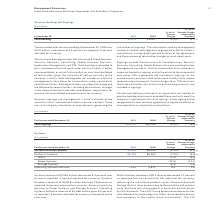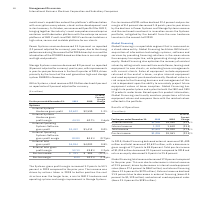According to International Business Machines's financial document, What caused the Systems Hardware revenue to decline? driven primarily by declines in Power Systems and Storage Systems.. The document states: "ent as reported (6 percent adjusted for currency), driven primarily by declines in Power Systems and Storage Systems. Operating Systems Software reven..." Also, What caused the IBM Z revenue to decline? IBM Z revenue decreased 1.1 percent as reported but was essentially flat adjusted for currency, reflecting the mainframe product cycles. Revenue declined through the first three quarters due to the end of the z14 product cycle, but there was strong growth in the fourth quarter driven by z15 shipments.. The document states: "Within Systems Hardware, IBM Z revenue decreased 1.1 percent as reported but was essentially flat adjusted for currency, reflecting the mainframe prod..." Also, What caused the Power Systems revenue to decline? due to the strong performance during the second half of 2018 driven by Linux and the introduction of the POWER9-based architecture in our mid-range and high-end products.. The document states: "d (12 percent adjusted for currency) year to year, due to the strong performance during the second half of 2018 driven by Linux and the introduction o..." Also, can you calculate: What is the average Systems external revenue? To answer this question, I need to perform calculations using the financial data. The calculation is: (7,604 + 8,034) / 2, which equals 7819 (in millions). This is based on the information: "Systems external revenue $7,604 $8,034 (5.3)% (4.1)% Systems external revenue $7,604 $8,034 (5.3)% (4.1)%..." The key data points involved are: 7,604, 8,034. Also, can you calculate: What is the average of Systems Hardware from 2018 to 2019? To answer this question, I need to perform calculations using the financial data. The calculation is: (5,918 + 6,363) / 2, which equals 6140.5 (in millions). This is based on the information: "Systems Hardware $5,918 $6,363 (7.0)% (5.9)% Systems Hardware $5,918 $6,363 (7.0)% (5.9)%..." The key data points involved are: 5,918, 6,363. Also, can you calculate: What is the increase / (decrease) in Operating Systems Software from 2018 to 2019? Based on the calculation: 1,686 - 1,671, the result is 15 (in millions). This is based on the information: "Operating Systems Software 1,686 1,671 0.9 2.6 Operating Systems Software 1,686 1,671 0.9 2.6..." The key data points involved are: 1,671, 1,686. 